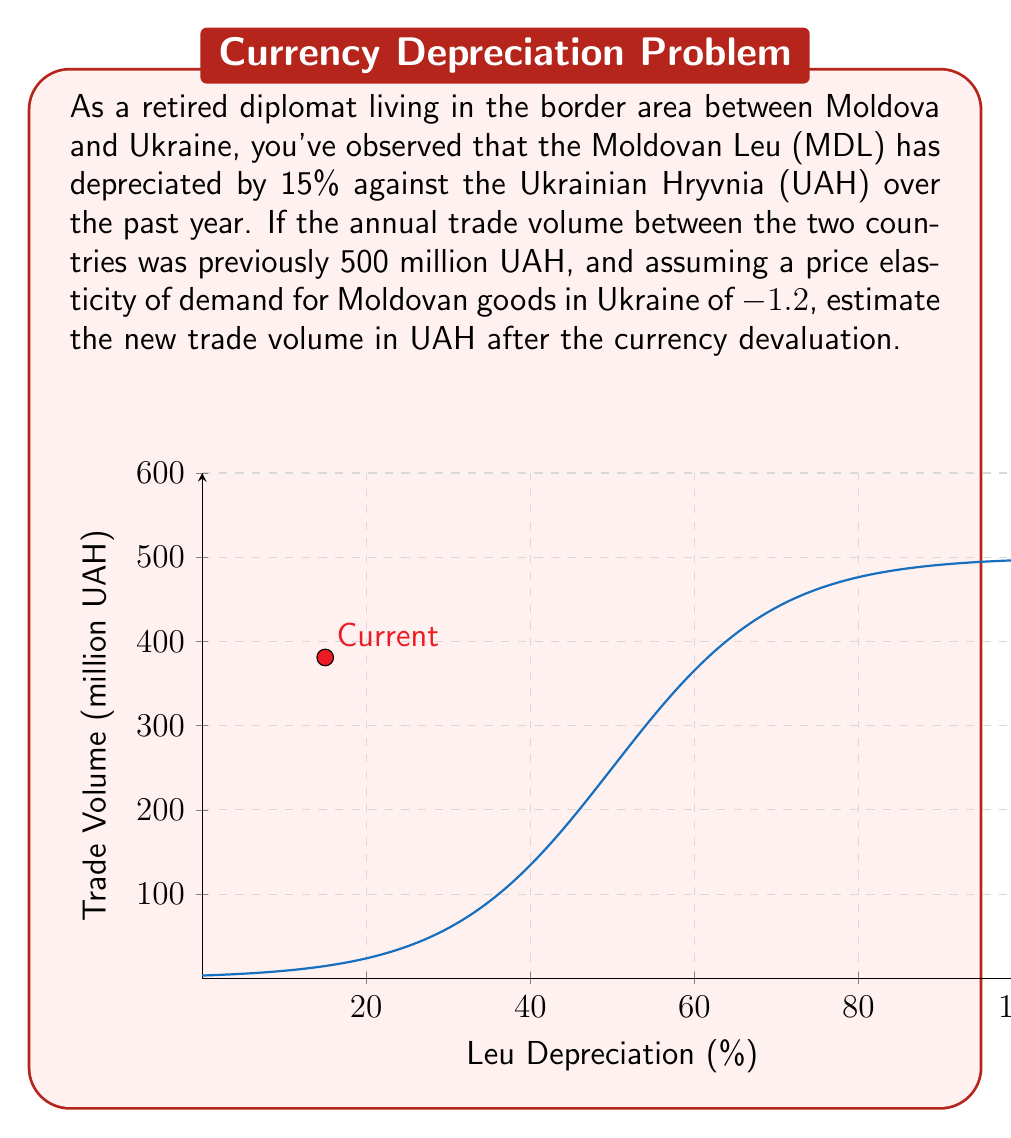Can you solve this math problem? Let's approach this step-by-step:

1) The price elasticity of demand is given as -1.2. This means:

   $$\text{Elasticity} = -1.2 = \frac{\text{% Change in Quantity}}{\text{% Change in Price}}$$

2) The Leu has depreciated by 15% against the Hryvnia. This effectively makes Moldovan goods 15% cheaper for Ukrainians. So, the % change in price is -15%.

3) We can use the elasticity formula to find the % change in quantity:

   $$-1.2 = \frac{\text{% Change in Quantity}}{-15\%}$$

4) Solving for % Change in Quantity:

   $$\text{% Change in Quantity} = -1.2 \times (-15\%) = 18\%$$

5) The original trade volume was 500 million UAH. An 18% increase would be:

   $$\text{Increase} = 500 \text{ million} \times 18\% = 90 \text{ million UAH}$$

6) Therefore, the new trade volume would be:

   $$\text{New Volume} = 500 \text{ million} + 90 \text{ million} = 590 \text{ million UAH}$$

This analysis assumes that other factors remain constant and that the full effect of the price change is reflected in the trade volume.
Answer: 590 million UAH 